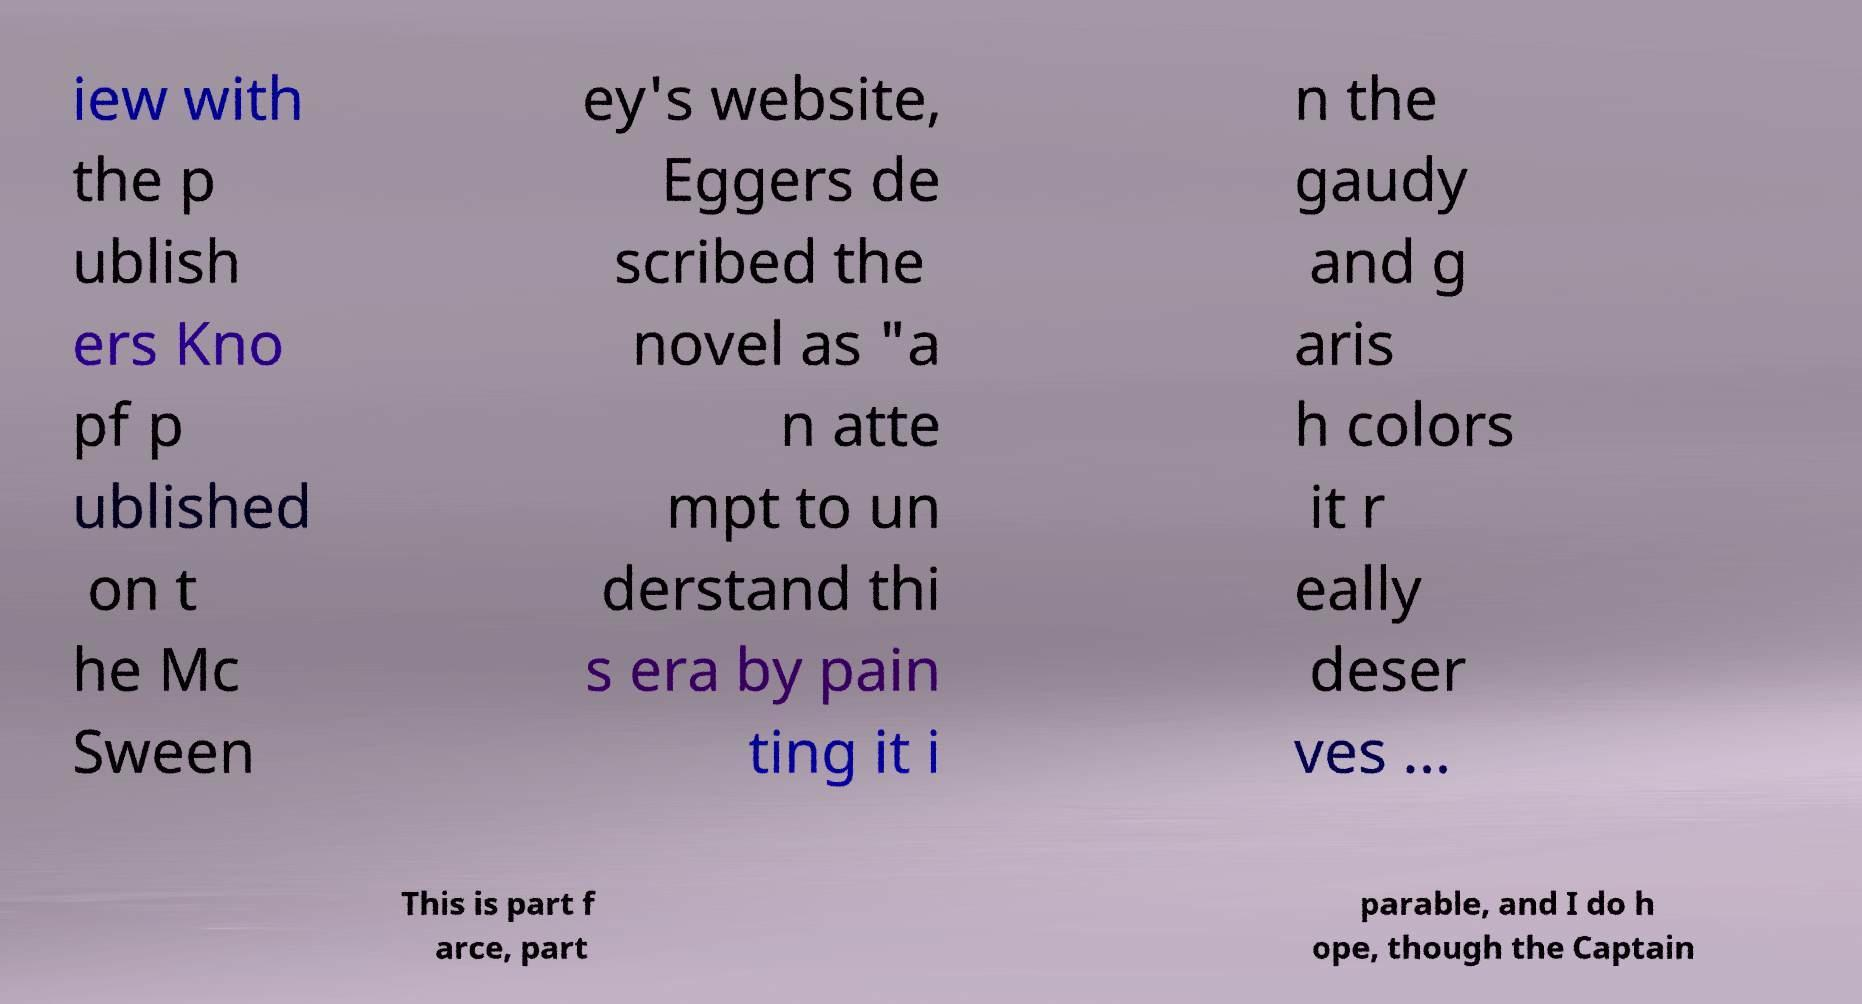Can you accurately transcribe the text from the provided image for me? iew with the p ublish ers Kno pf p ublished on t he Mc Sween ey's website, Eggers de scribed the novel as "a n atte mpt to un derstand thi s era by pain ting it i n the gaudy and g aris h colors it r eally deser ves ... This is part f arce, part parable, and I do h ope, though the Captain 